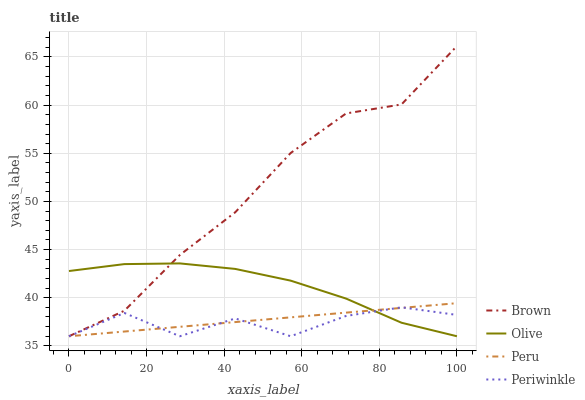Does Brown have the minimum area under the curve?
Answer yes or no. No. Does Periwinkle have the maximum area under the curve?
Answer yes or no. No. Is Brown the smoothest?
Answer yes or no. No. Is Brown the roughest?
Answer yes or no. No. Does Periwinkle have the highest value?
Answer yes or no. No. 